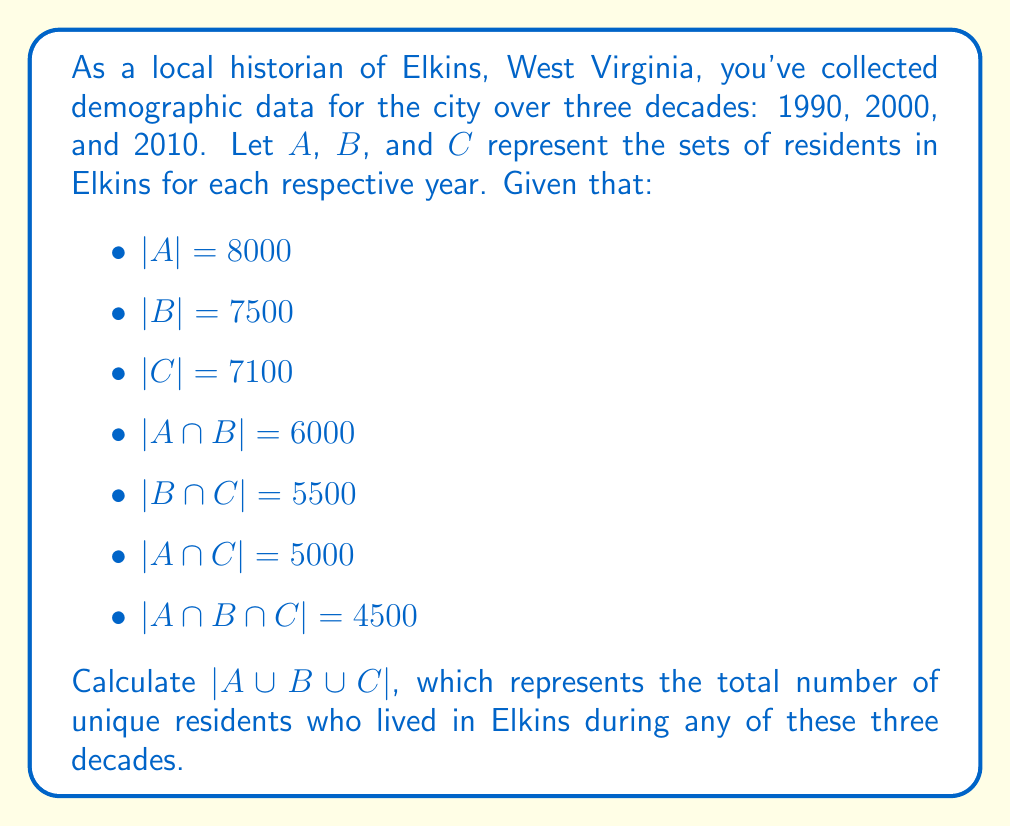Provide a solution to this math problem. To solve this problem, we'll use the Inclusion-Exclusion Principle for three sets:

$$|A \cup B \cup C| = |A| + |B| + |C| - |A \cap B| - |B \cap C| - |A \cap C| + |A \cap B \cap C|$$

Let's substitute the given values:

$$|A \cup B \cup C| = 8000 + 7500 + 7100 - 6000 - 5500 - 5000 + 4500$$

Now, let's calculate step by step:

1) First, add the cardinalities of individual sets:
   $8000 + 7500 + 7100 = 22600$

2) Then, subtract the cardinalities of pairwise intersections:
   $22600 - 6000 - 5500 - 5000 = 6100$

3) Finally, add back the cardinality of the triple intersection:
   $6100 + 4500 = 10600$

Therefore, $|A \cup B \cup C| = 10600$.
Answer: 10600 